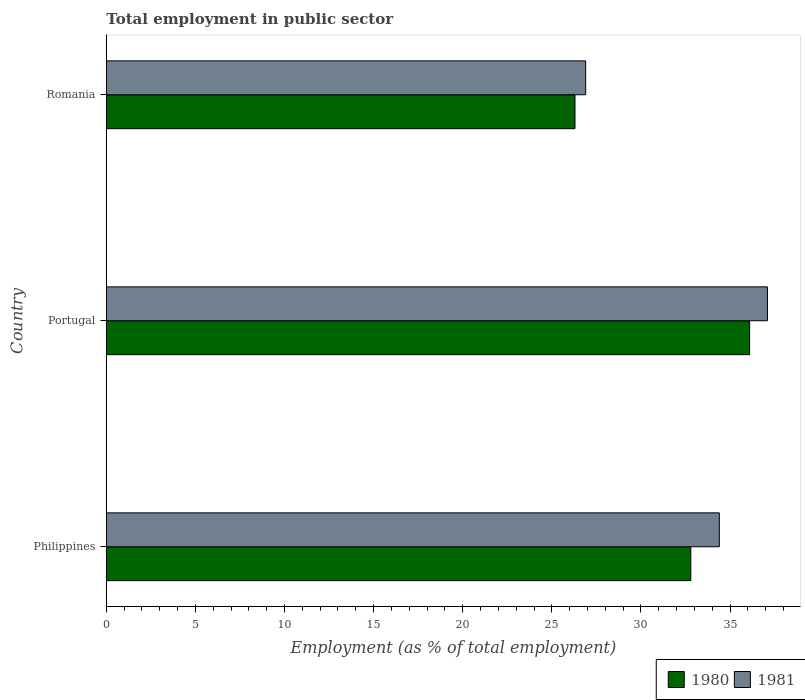How many groups of bars are there?
Keep it short and to the point. 3. Are the number of bars per tick equal to the number of legend labels?
Your response must be concise. Yes. What is the label of the 3rd group of bars from the top?
Provide a succinct answer. Philippines. In how many cases, is the number of bars for a given country not equal to the number of legend labels?
Offer a very short reply. 0. What is the employment in public sector in 1981 in Portugal?
Offer a terse response. 37.1. Across all countries, what is the maximum employment in public sector in 1980?
Your answer should be compact. 36.1. Across all countries, what is the minimum employment in public sector in 1980?
Give a very brief answer. 26.3. In which country was the employment in public sector in 1981 maximum?
Your response must be concise. Portugal. In which country was the employment in public sector in 1981 minimum?
Your response must be concise. Romania. What is the total employment in public sector in 1981 in the graph?
Provide a succinct answer. 98.4. What is the difference between the employment in public sector in 1980 in Portugal and that in Romania?
Your response must be concise. 9.8. What is the difference between the employment in public sector in 1980 in Philippines and the employment in public sector in 1981 in Romania?
Give a very brief answer. 5.9. What is the average employment in public sector in 1981 per country?
Your answer should be very brief. 32.8. What is the difference between the employment in public sector in 1981 and employment in public sector in 1980 in Romania?
Offer a very short reply. 0.6. What is the ratio of the employment in public sector in 1981 in Philippines to that in Portugal?
Offer a terse response. 0.93. What is the difference between the highest and the second highest employment in public sector in 1980?
Your answer should be very brief. 3.3. What is the difference between the highest and the lowest employment in public sector in 1980?
Your response must be concise. 9.8. How many bars are there?
Your answer should be compact. 6. Are all the bars in the graph horizontal?
Offer a terse response. Yes. Does the graph contain any zero values?
Provide a short and direct response. No. How many legend labels are there?
Your response must be concise. 2. How are the legend labels stacked?
Offer a very short reply. Horizontal. What is the title of the graph?
Your response must be concise. Total employment in public sector. Does "1987" appear as one of the legend labels in the graph?
Provide a succinct answer. No. What is the label or title of the X-axis?
Offer a terse response. Employment (as % of total employment). What is the label or title of the Y-axis?
Give a very brief answer. Country. What is the Employment (as % of total employment) in 1980 in Philippines?
Provide a succinct answer. 32.8. What is the Employment (as % of total employment) in 1981 in Philippines?
Provide a succinct answer. 34.4. What is the Employment (as % of total employment) in 1980 in Portugal?
Provide a short and direct response. 36.1. What is the Employment (as % of total employment) in 1981 in Portugal?
Offer a terse response. 37.1. What is the Employment (as % of total employment) of 1980 in Romania?
Offer a very short reply. 26.3. What is the Employment (as % of total employment) in 1981 in Romania?
Ensure brevity in your answer.  26.9. Across all countries, what is the maximum Employment (as % of total employment) of 1980?
Give a very brief answer. 36.1. Across all countries, what is the maximum Employment (as % of total employment) in 1981?
Your answer should be compact. 37.1. Across all countries, what is the minimum Employment (as % of total employment) in 1980?
Make the answer very short. 26.3. Across all countries, what is the minimum Employment (as % of total employment) of 1981?
Offer a very short reply. 26.9. What is the total Employment (as % of total employment) in 1980 in the graph?
Your answer should be compact. 95.2. What is the total Employment (as % of total employment) in 1981 in the graph?
Offer a very short reply. 98.4. What is the difference between the Employment (as % of total employment) of 1980 in Portugal and that in Romania?
Ensure brevity in your answer.  9.8. What is the average Employment (as % of total employment) of 1980 per country?
Offer a terse response. 31.73. What is the average Employment (as % of total employment) in 1981 per country?
Provide a succinct answer. 32.8. What is the difference between the Employment (as % of total employment) of 1980 and Employment (as % of total employment) of 1981 in Philippines?
Your answer should be compact. -1.6. What is the difference between the Employment (as % of total employment) of 1980 and Employment (as % of total employment) of 1981 in Romania?
Give a very brief answer. -0.6. What is the ratio of the Employment (as % of total employment) in 1980 in Philippines to that in Portugal?
Make the answer very short. 0.91. What is the ratio of the Employment (as % of total employment) of 1981 in Philippines to that in Portugal?
Your answer should be compact. 0.93. What is the ratio of the Employment (as % of total employment) of 1980 in Philippines to that in Romania?
Offer a very short reply. 1.25. What is the ratio of the Employment (as % of total employment) of 1981 in Philippines to that in Romania?
Provide a short and direct response. 1.28. What is the ratio of the Employment (as % of total employment) in 1980 in Portugal to that in Romania?
Provide a short and direct response. 1.37. What is the ratio of the Employment (as % of total employment) of 1981 in Portugal to that in Romania?
Make the answer very short. 1.38. What is the difference between the highest and the second highest Employment (as % of total employment) of 1980?
Your answer should be compact. 3.3. What is the difference between the highest and the lowest Employment (as % of total employment) of 1980?
Offer a terse response. 9.8. What is the difference between the highest and the lowest Employment (as % of total employment) of 1981?
Offer a terse response. 10.2. 